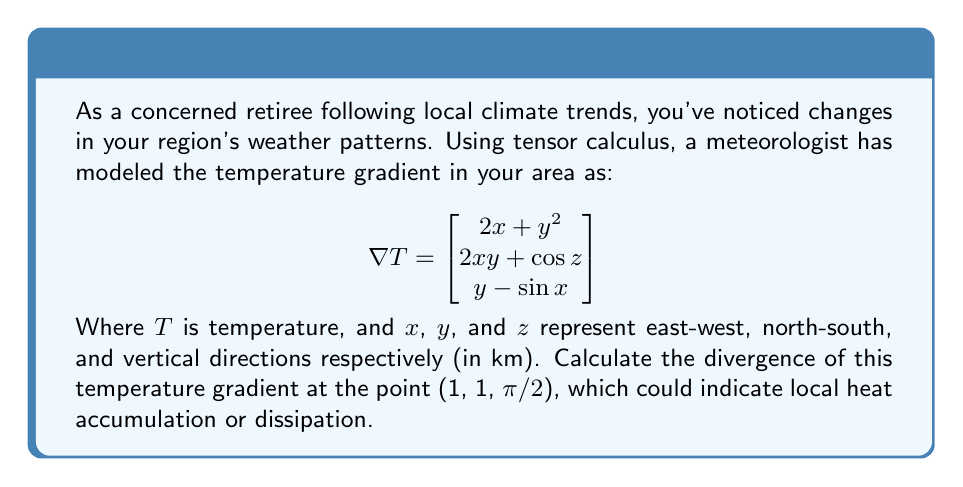Can you solve this math problem? To solve this problem, we need to calculate the divergence of the given vector field (temperature gradient) at the specified point. The divergence is given by:

$$\text{div}(\nabla T) = \nabla \cdot (\nabla T) = \frac{\partial}{\partial x}(2x + y^2) + \frac{\partial}{\partial y}(2xy + \cos z) + \frac{\partial}{\partial z}(y - \sin x)$$

Let's calculate each term:

1) $\frac{\partial}{\partial x}(2x + y^2) = 2$

2) $\frac{\partial}{\partial y}(2xy + \cos z) = 2x$

3) $\frac{\partial}{\partial z}(y - \sin x) = 0$

Now, we sum these terms:

$$\text{div}(\nabla T) = 2 + 2x + 0 = 2 + 2x$$

At the point (1, 1, π/2), we substitute x = 1:

$$\text{div}(\nabla T) = 2 + 2(1) = 4$$

This positive divergence indicates a local accumulation of heat at the given point.
Answer: 4 